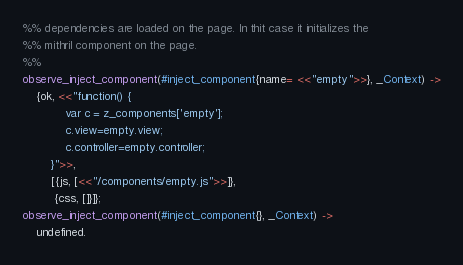Convert code to text. <code><loc_0><loc_0><loc_500><loc_500><_Erlang_>%% dependencies are loaded on the page. In thit case it initializes the
%% mithril component on the page.
%% 
observe_inject_component(#inject_component{name= <<"empty">>}, _Context) ->
    {ok, <<"function() {
            var c = z_components['empty'];
            c.view=empty.view;
            c.controller=empty.controller;
        }">>,
        [{js, [<<"/components/empty.js">>]},
         {css, []}]};
observe_inject_component(#inject_component{}, _Context) ->
    undefined.
</code> 